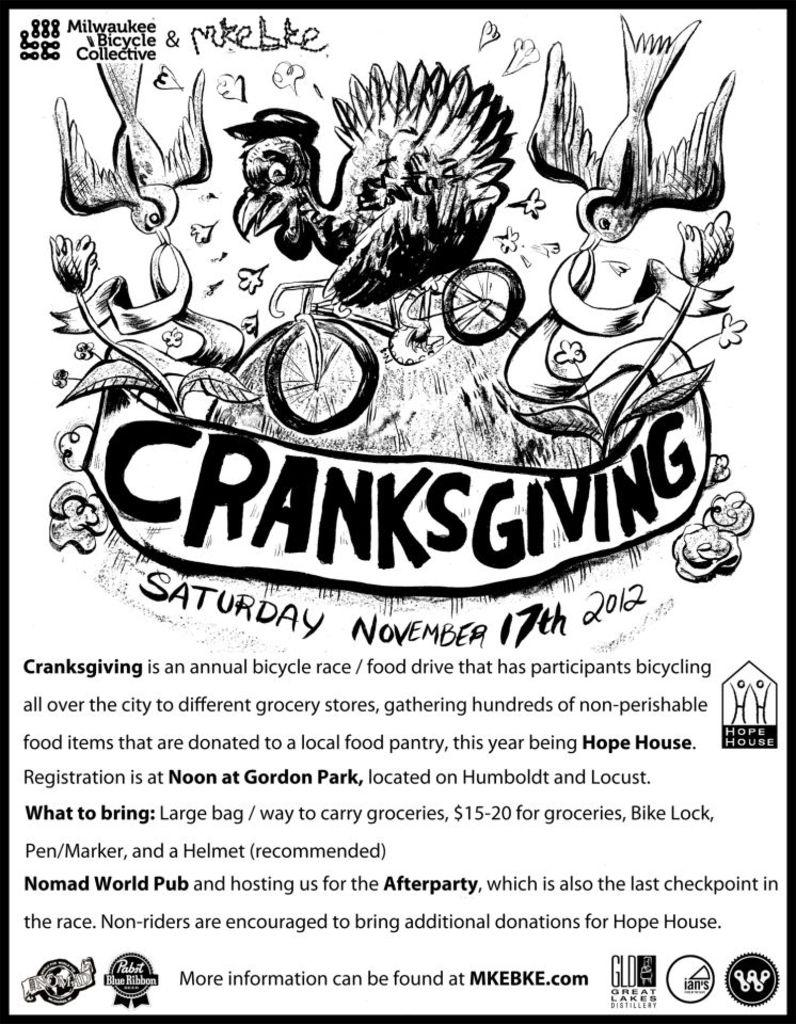<image>
Present a compact description of the photo's key features. A bicycle race if called Cranksgiving and is on November 17th 2012. 